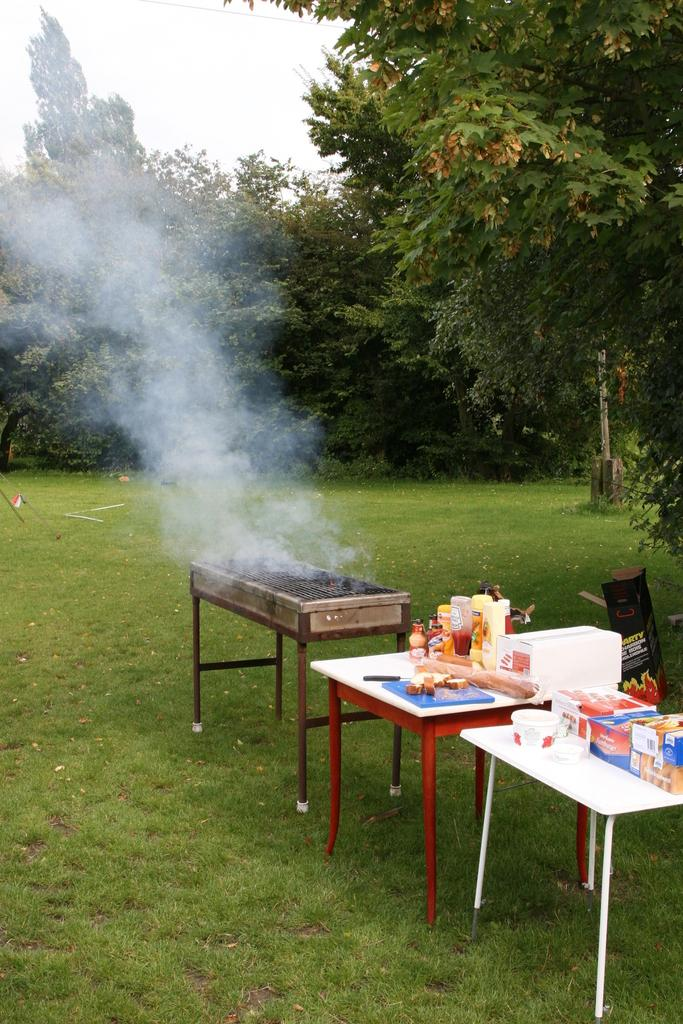What surfaces are the objects placed on in the image? The objects are placed on tables and on the grass in the image. What type of natural environment is visible in the image? There are trees visible in the image, indicating a natural environment. What is visible in the background of the image? The sky is visible in the image. What color is the paint used to decorate the owner's house in the image? There is no mention of a house or an owner in the image, nor is there any reference to paint. 